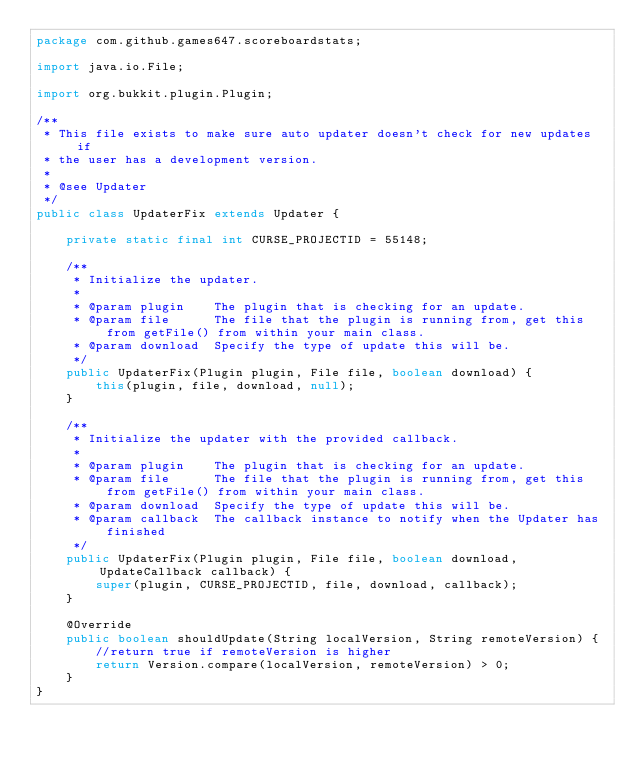Convert code to text. <code><loc_0><loc_0><loc_500><loc_500><_Java_>package com.github.games647.scoreboardstats;

import java.io.File;

import org.bukkit.plugin.Plugin;

/**
 * This file exists to make sure auto updater doesn't check for new updates if
 * the user has a development version.
 *
 * @see Updater
 */
public class UpdaterFix extends Updater {

    private static final int CURSE_PROJECTID = 55148;

    /**
     * Initialize the updater.
     *
     * @param plugin    The plugin that is checking for an update.
     * @param file      The file that the plugin is running from, get this from getFile() from within your main class.
     * @param download  Specify the type of update this will be.
     */
    public UpdaterFix(Plugin plugin, File file, boolean download) {
        this(plugin, file, download, null);
    }

    /**
     * Initialize the updater with the provided callback.
     *
     * @param plugin    The plugin that is checking for an update.
     * @param file      The file that the plugin is running from, get this from getFile() from within your main class.
     * @param download  Specify the type of update this will be.
     * @param callback  The callback instance to notify when the Updater has finished
     */
    public UpdaterFix(Plugin plugin, File file, boolean download, UpdateCallback callback) {
        super(plugin, CURSE_PROJECTID, file, download, callback);
    }

    @Override
    public boolean shouldUpdate(String localVersion, String remoteVersion) {
        //return true if remoteVersion is higher
        return Version.compare(localVersion, remoteVersion) > 0;
    }
}
</code> 